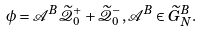<formula> <loc_0><loc_0><loc_500><loc_500>\phi = \mathcal { A } ^ { B } \widetilde { \mathcal { Q } } ^ { + } _ { 0 } + \widetilde { \mathcal { Q } } ^ { - } _ { 0 } , \mathcal { A } ^ { B } \in \widetilde { G } ^ { B } _ { N } .</formula> 